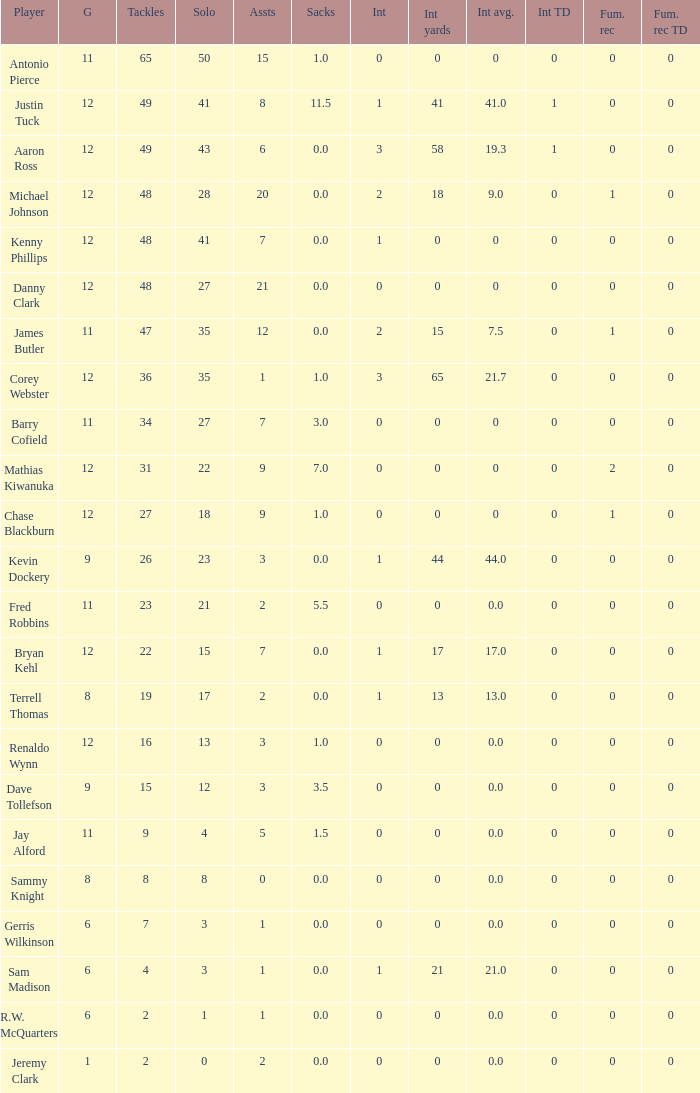5 sacks? 15.0. 